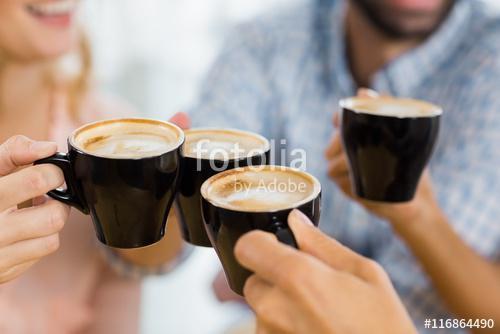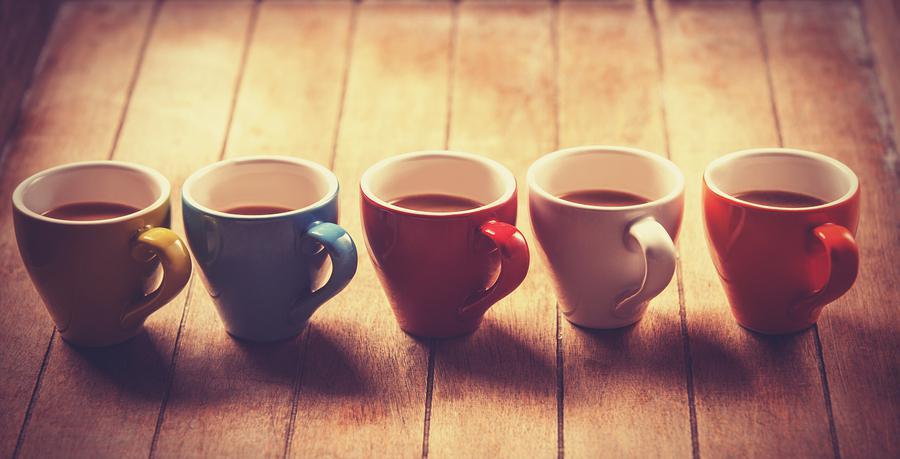The first image is the image on the left, the second image is the image on the right. Evaluate the accuracy of this statement regarding the images: "In at least one image there is a total of four cups.". Is it true? Answer yes or no. Yes. The first image is the image on the left, the second image is the image on the right. Evaluate the accuracy of this statement regarding the images: "There are fewer than ten cups in total.". Is it true? Answer yes or no. Yes. 